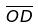<formula> <loc_0><loc_0><loc_500><loc_500>\overline { O D }</formula> 